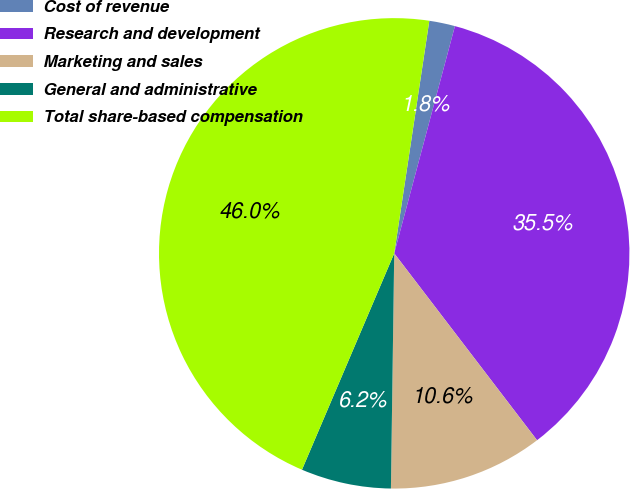Convert chart. <chart><loc_0><loc_0><loc_500><loc_500><pie_chart><fcel>Cost of revenue<fcel>Research and development<fcel>Marketing and sales<fcel>General and administrative<fcel>Total share-based compensation<nl><fcel>1.77%<fcel>35.46%<fcel>10.61%<fcel>6.19%<fcel>45.97%<nl></chart> 